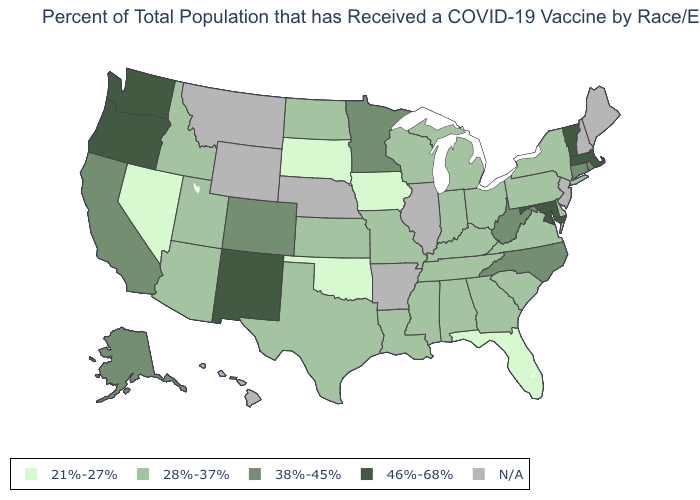Name the states that have a value in the range 38%-45%?
Concise answer only. Alaska, California, Colorado, Connecticut, Minnesota, North Carolina, Rhode Island, West Virginia. What is the value of Arkansas?
Write a very short answer. N/A. Among the states that border Pennsylvania , which have the highest value?
Keep it brief. Maryland. What is the highest value in states that border Vermont?
Answer briefly. 46%-68%. What is the highest value in the USA?
Give a very brief answer. 46%-68%. Is the legend a continuous bar?
Be succinct. No. Does the map have missing data?
Quick response, please. Yes. Name the states that have a value in the range N/A?
Be succinct. Arkansas, Hawaii, Illinois, Maine, Montana, Nebraska, New Hampshire, New Jersey, Wyoming. Name the states that have a value in the range 28%-37%?
Give a very brief answer. Alabama, Arizona, Delaware, Georgia, Idaho, Indiana, Kansas, Kentucky, Louisiana, Michigan, Mississippi, Missouri, New York, North Dakota, Ohio, Pennsylvania, South Carolina, Tennessee, Texas, Utah, Virginia, Wisconsin. Name the states that have a value in the range N/A?
Short answer required. Arkansas, Hawaii, Illinois, Maine, Montana, Nebraska, New Hampshire, New Jersey, Wyoming. What is the lowest value in the Northeast?
Concise answer only. 28%-37%. Among the states that border Delaware , which have the highest value?
Be succinct. Maryland. Among the states that border Oklahoma , which have the highest value?
Keep it brief. New Mexico. 